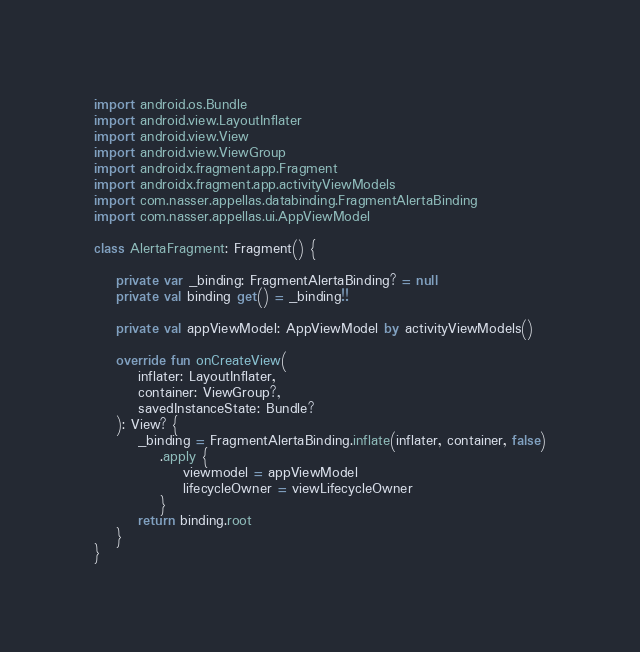Convert code to text. <code><loc_0><loc_0><loc_500><loc_500><_Kotlin_>import android.os.Bundle
import android.view.LayoutInflater
import android.view.View
import android.view.ViewGroup
import androidx.fragment.app.Fragment
import androidx.fragment.app.activityViewModels
import com.nasser.appellas.databinding.FragmentAlertaBinding
import com.nasser.appellas.ui.AppViewModel

class AlertaFragment: Fragment() {

    private var _binding: FragmentAlertaBinding? = null
    private val binding get() = _binding!!

    private val appViewModel: AppViewModel by activityViewModels()

    override fun onCreateView(
        inflater: LayoutInflater,
        container: ViewGroup?,
        savedInstanceState: Bundle?
    ): View? {
        _binding = FragmentAlertaBinding.inflate(inflater, container, false)
            .apply {
                viewmodel = appViewModel
                lifecycleOwner = viewLifecycleOwner
            }
        return binding.root
    }
}

</code> 